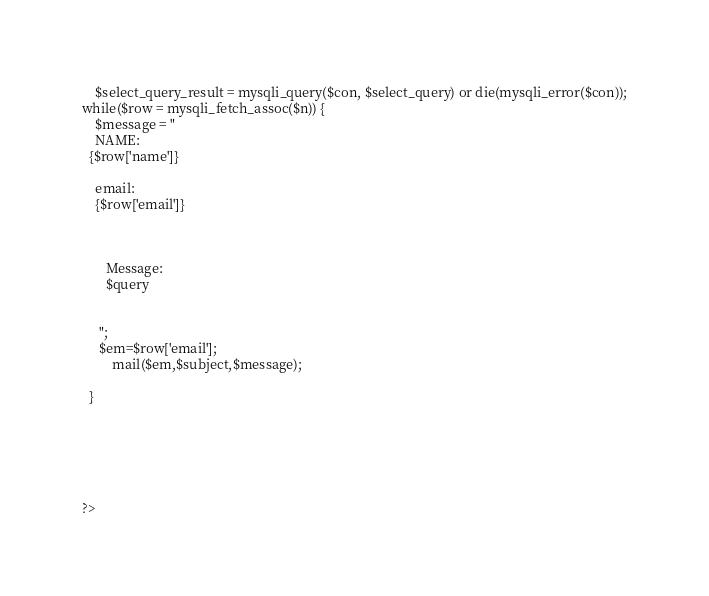Convert code to text. <code><loc_0><loc_0><loc_500><loc_500><_PHP_>    $select_query_result = mysqli_query($con, $select_query) or die(mysqli_error($con));
while($row = mysqli_fetch_assoc($n)) {
    $message = "
    NAME:
  {$row['name']}

    email:
    {$row['email']}



       Message:
       $query


     ";
     $em=$row['email'];
         mail($em,$subject,$message);

  }






?>
</code> 